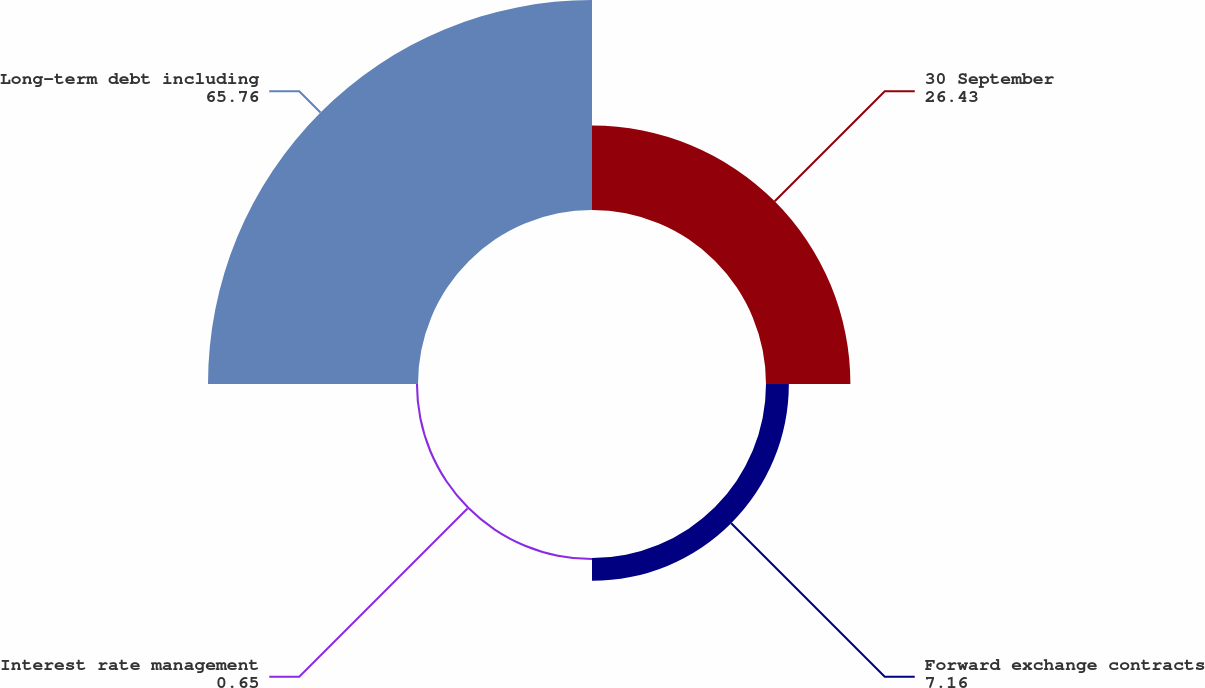Convert chart to OTSL. <chart><loc_0><loc_0><loc_500><loc_500><pie_chart><fcel>30 September<fcel>Forward exchange contracts<fcel>Interest rate management<fcel>Long-term debt including<nl><fcel>26.43%<fcel>7.16%<fcel>0.65%<fcel>65.76%<nl></chart> 